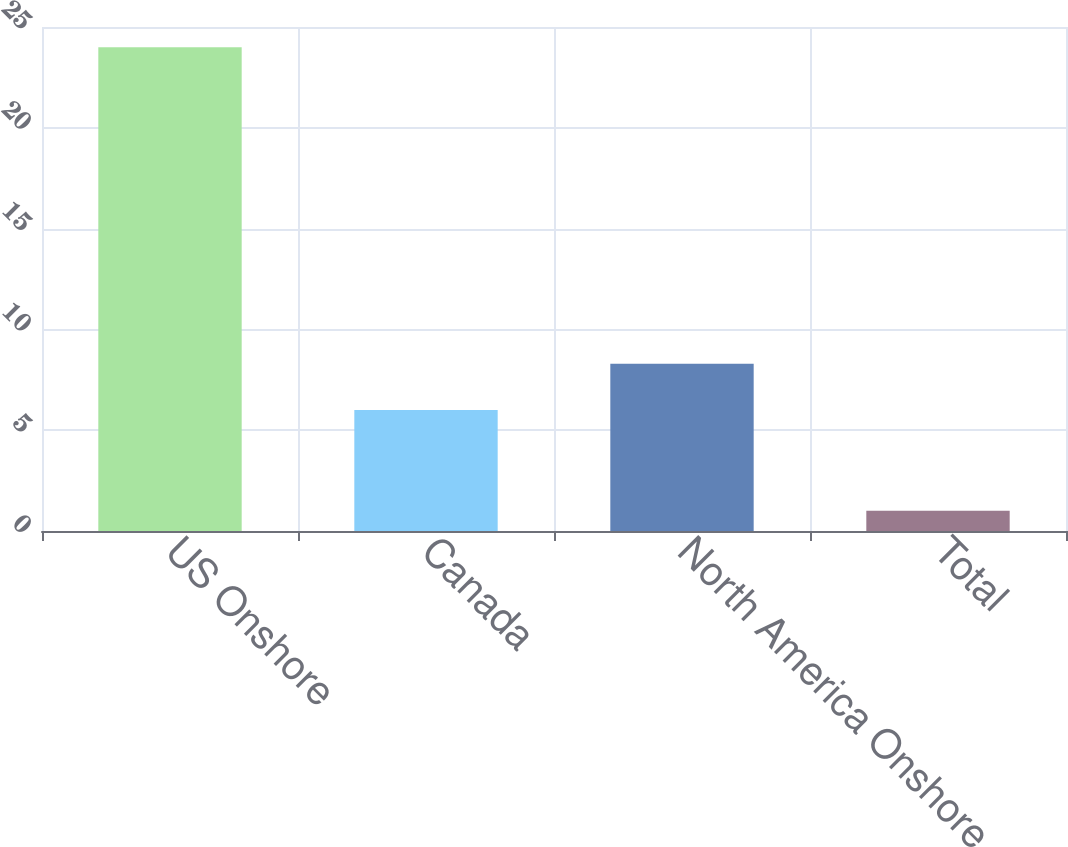Convert chart to OTSL. <chart><loc_0><loc_0><loc_500><loc_500><bar_chart><fcel>US Onshore<fcel>Canada<fcel>North America Onshore<fcel>Total<nl><fcel>24<fcel>6<fcel>8.3<fcel>1<nl></chart> 